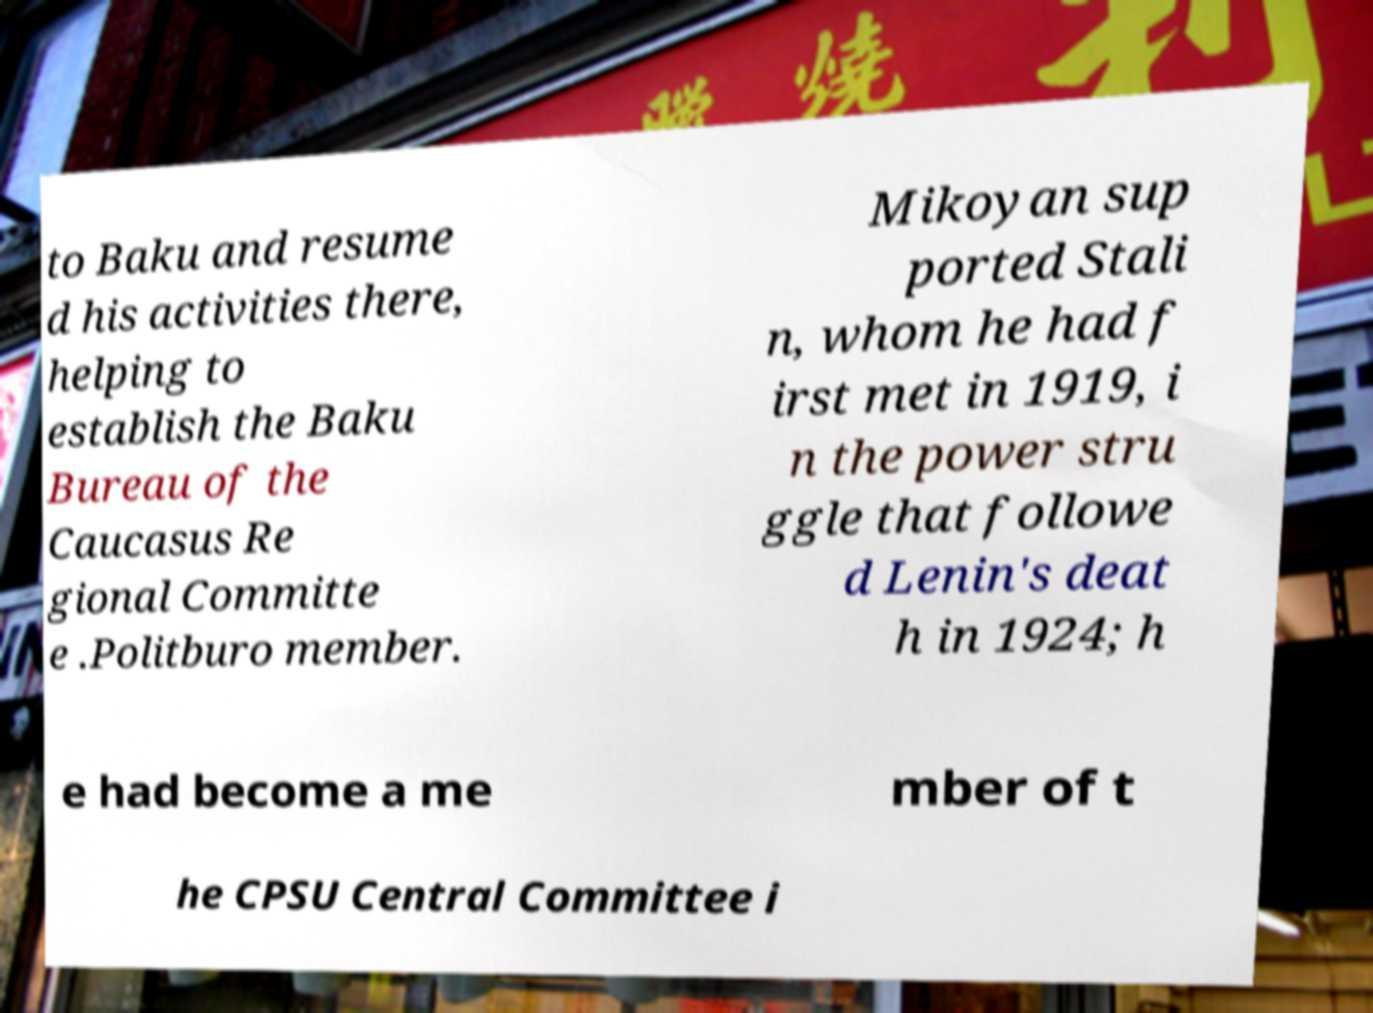I need the written content from this picture converted into text. Can you do that? to Baku and resume d his activities there, helping to establish the Baku Bureau of the Caucasus Re gional Committe e .Politburo member. Mikoyan sup ported Stali n, whom he had f irst met in 1919, i n the power stru ggle that followe d Lenin's deat h in 1924; h e had become a me mber of t he CPSU Central Committee i 